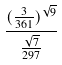Convert formula to latex. <formula><loc_0><loc_0><loc_500><loc_500>\frac { ( \frac { 3 } { 3 6 1 } ) ^ { \sqrt { 9 } } } { \frac { \sqrt { 7 } } { 2 9 7 } }</formula> 